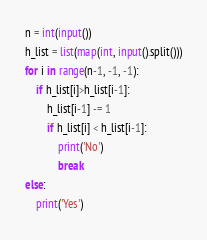<code> <loc_0><loc_0><loc_500><loc_500><_Python_>n = int(input())
h_list = list(map(int, input().split()))
for i in range(n-1, -1, -1):
    if h_list[i]>h_list[i-1]:
        h_list[i-1] -= 1
        if h_list[i] < h_list[i-1]:
            print('No')
            break
else:
    print('Yes')</code> 